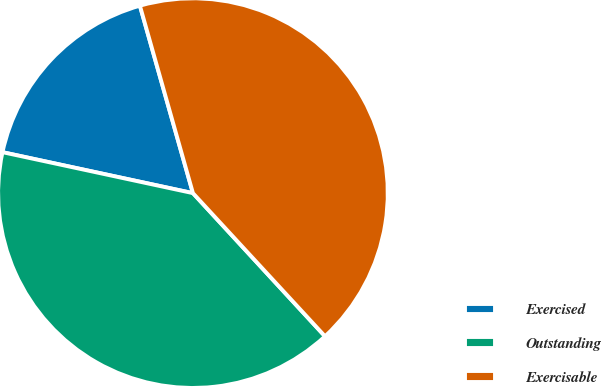Convert chart. <chart><loc_0><loc_0><loc_500><loc_500><pie_chart><fcel>Exercised<fcel>Outstanding<fcel>Exercisable<nl><fcel>17.24%<fcel>40.23%<fcel>42.53%<nl></chart> 